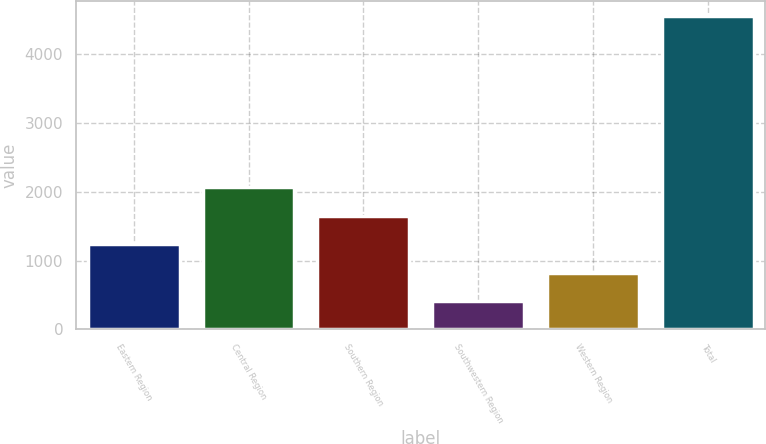Convert chart. <chart><loc_0><loc_0><loc_500><loc_500><bar_chart><fcel>Eastern Region<fcel>Central Region<fcel>Southern Region<fcel>Southwestern Region<fcel>Western Region<fcel>Total<nl><fcel>1238.34<fcel>2067.28<fcel>1652.81<fcel>409.4<fcel>823.87<fcel>4554.1<nl></chart> 